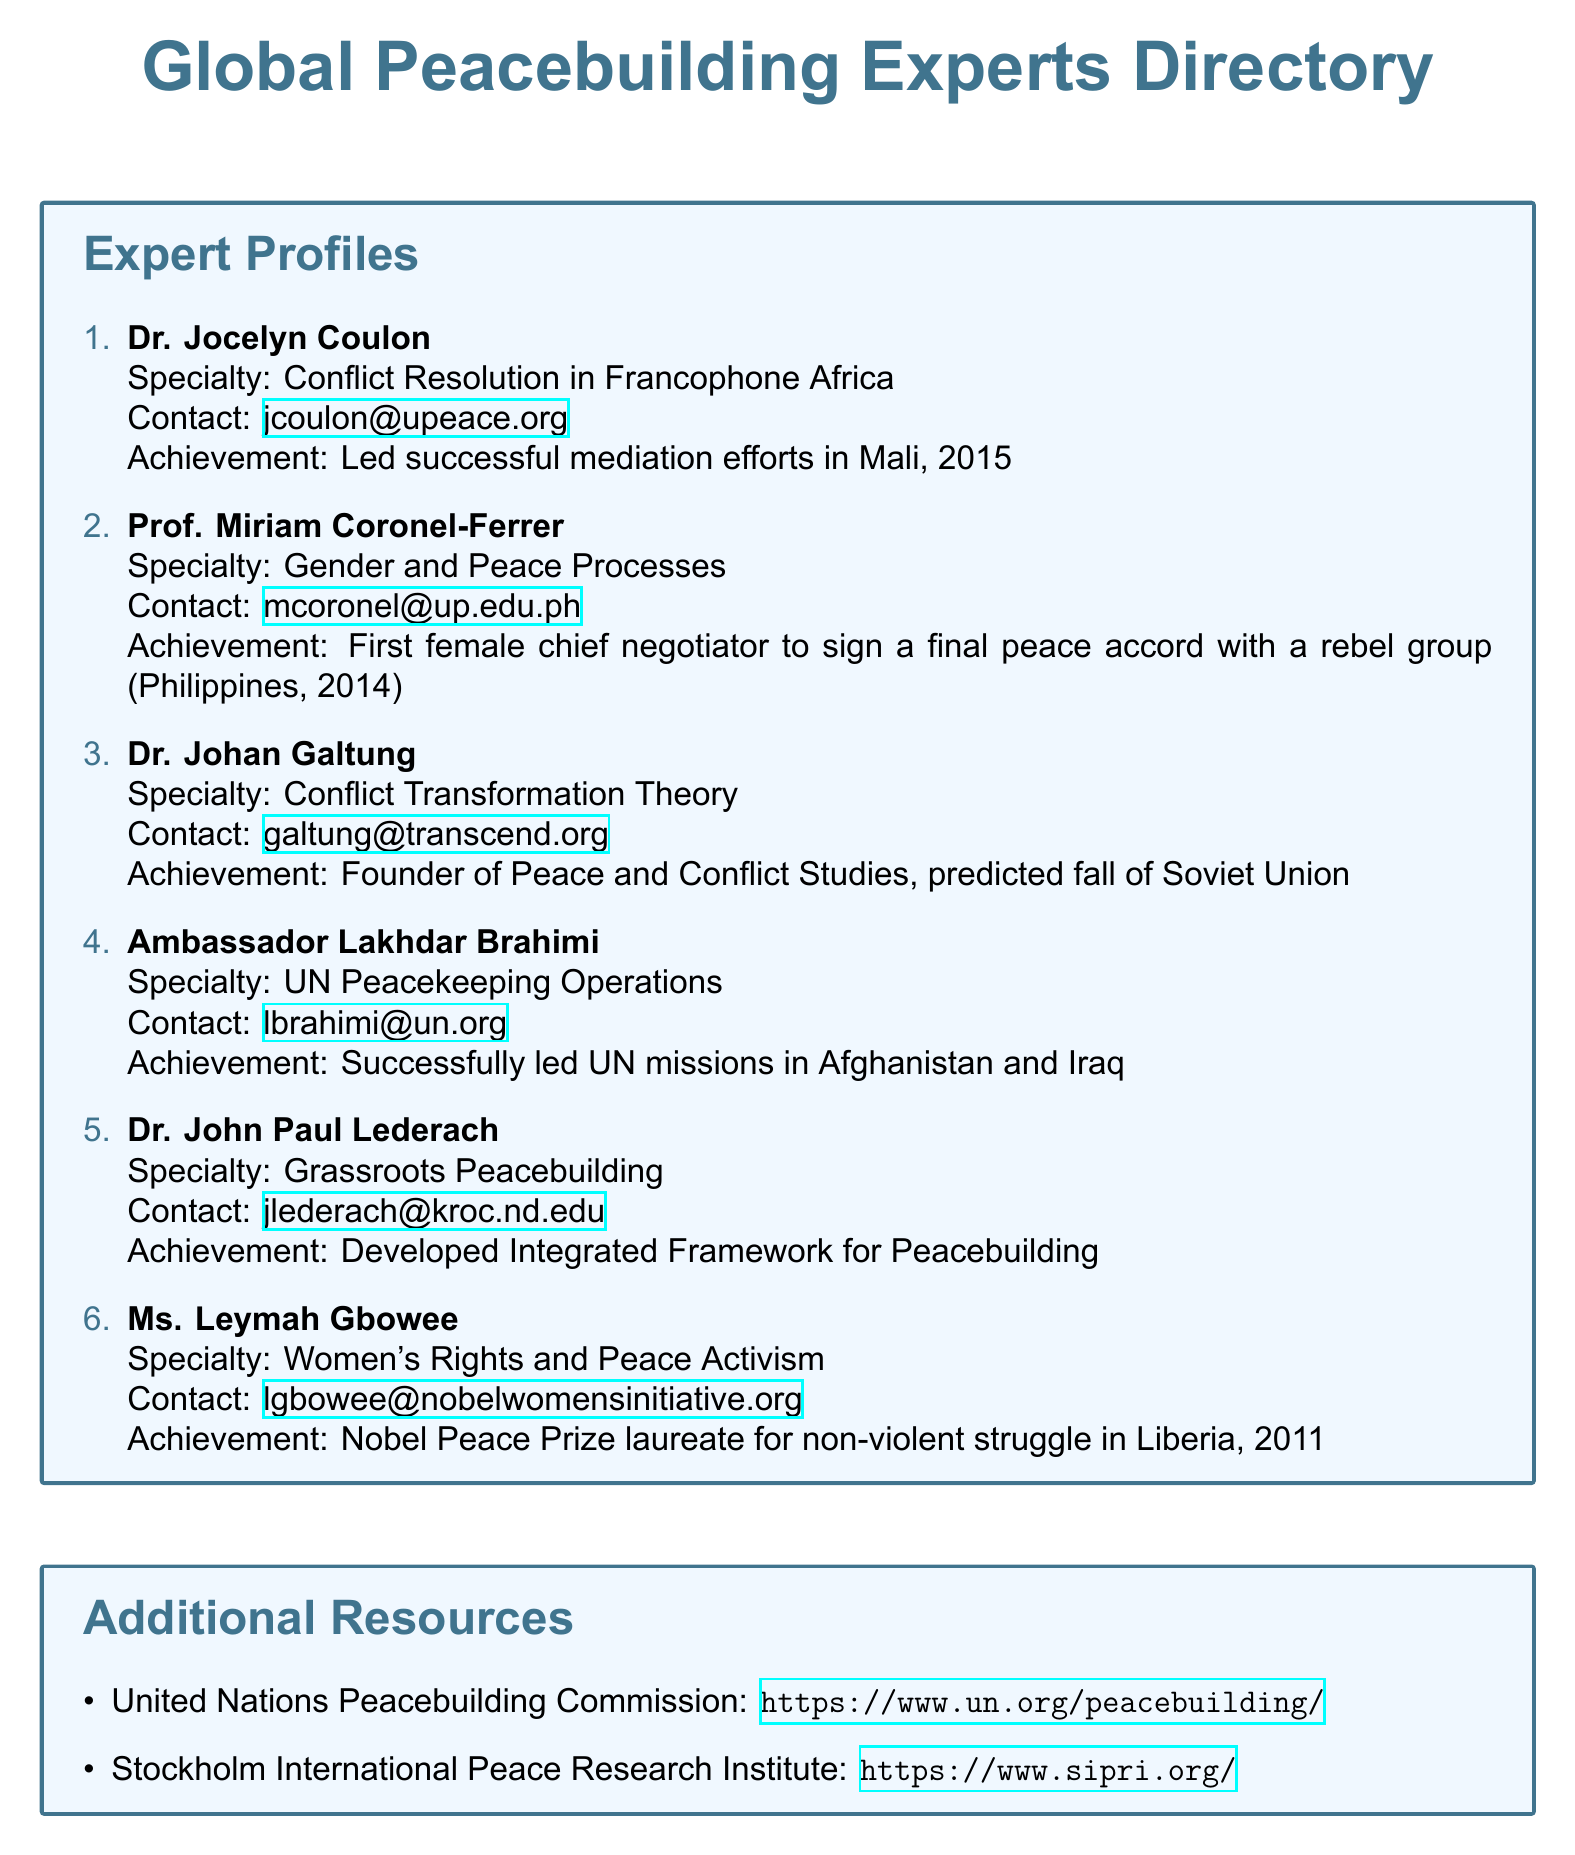What is the specialty of Dr. Jocelyn Coulon? Dr. Jocelyn Coulon specializes in Conflict Resolution in Francophone Africa.
Answer: Conflict Resolution in Francophone Africa Who is the first female chief negotiator to sign a peace accord? Prof. Miriam Coronel-Ferrer was the first female chief negotiator to sign a final peace accord with a rebel group (Philippines, 2014).
Answer: Prof. Miriam Coronel-Ferrer What significant prediction did Dr. Johan Galtung make? Dr. Johan Galtung predicted the fall of the Soviet Union.
Answer: Predicted fall of Soviet Union In which two countries did Ambassador Lakhdar Brahimi lead UN missions? Ambassador Lakhdar Brahimi led UN missions in Afghanistan and Iraq.
Answer: Afghanistan and Iraq What notable achievement is associated with Ms. Leymah Gbowee? Ms. Leymah Gbowee received the Nobel Peace Prize for her non-violent struggle in Liberia, 2011.
Answer: Nobel Peace Prize laureate for non-violent struggle in Liberia, 2011 What is the focus of Dr. John Paul Lederach's work? Dr. John Paul Lederach focuses on Grassroots Peacebuilding.
Answer: Grassroots Peacebuilding What organization is mentioned as a resource for peacebuilding? The United Nations Peacebuilding Commission is mentioned as a resource.
Answer: United Nations Peacebuilding Commission What is the purpose of the catalog? The catalog is designed to provide information on global peacebuilding experts, including their specialties, contact information, and notable achievements.
Answer: To provide information on global peacebuilding experts How many experts are listed in the directory? There are six experts listed in the directory.
Answer: Six experts 